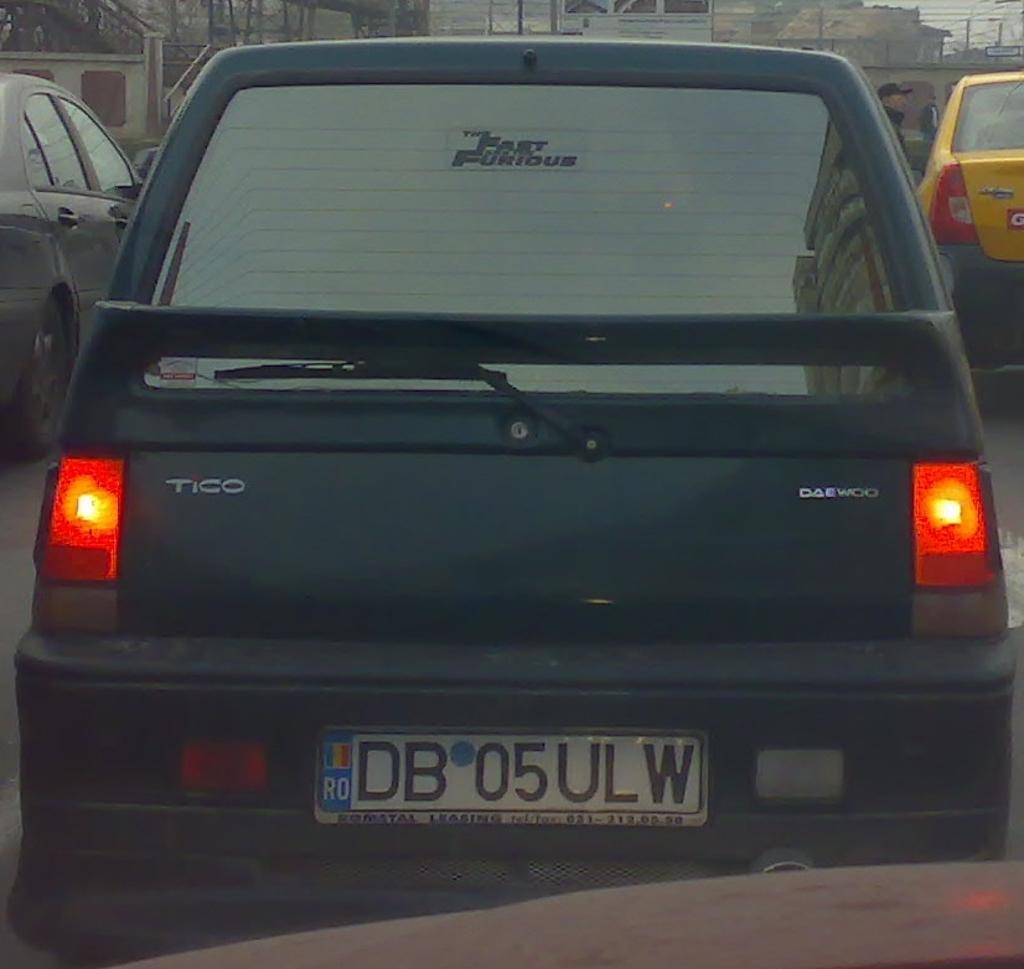<image>
Give a short and clear explanation of the subsequent image. A Daewoo vehicle called Tico is stopped in front. 